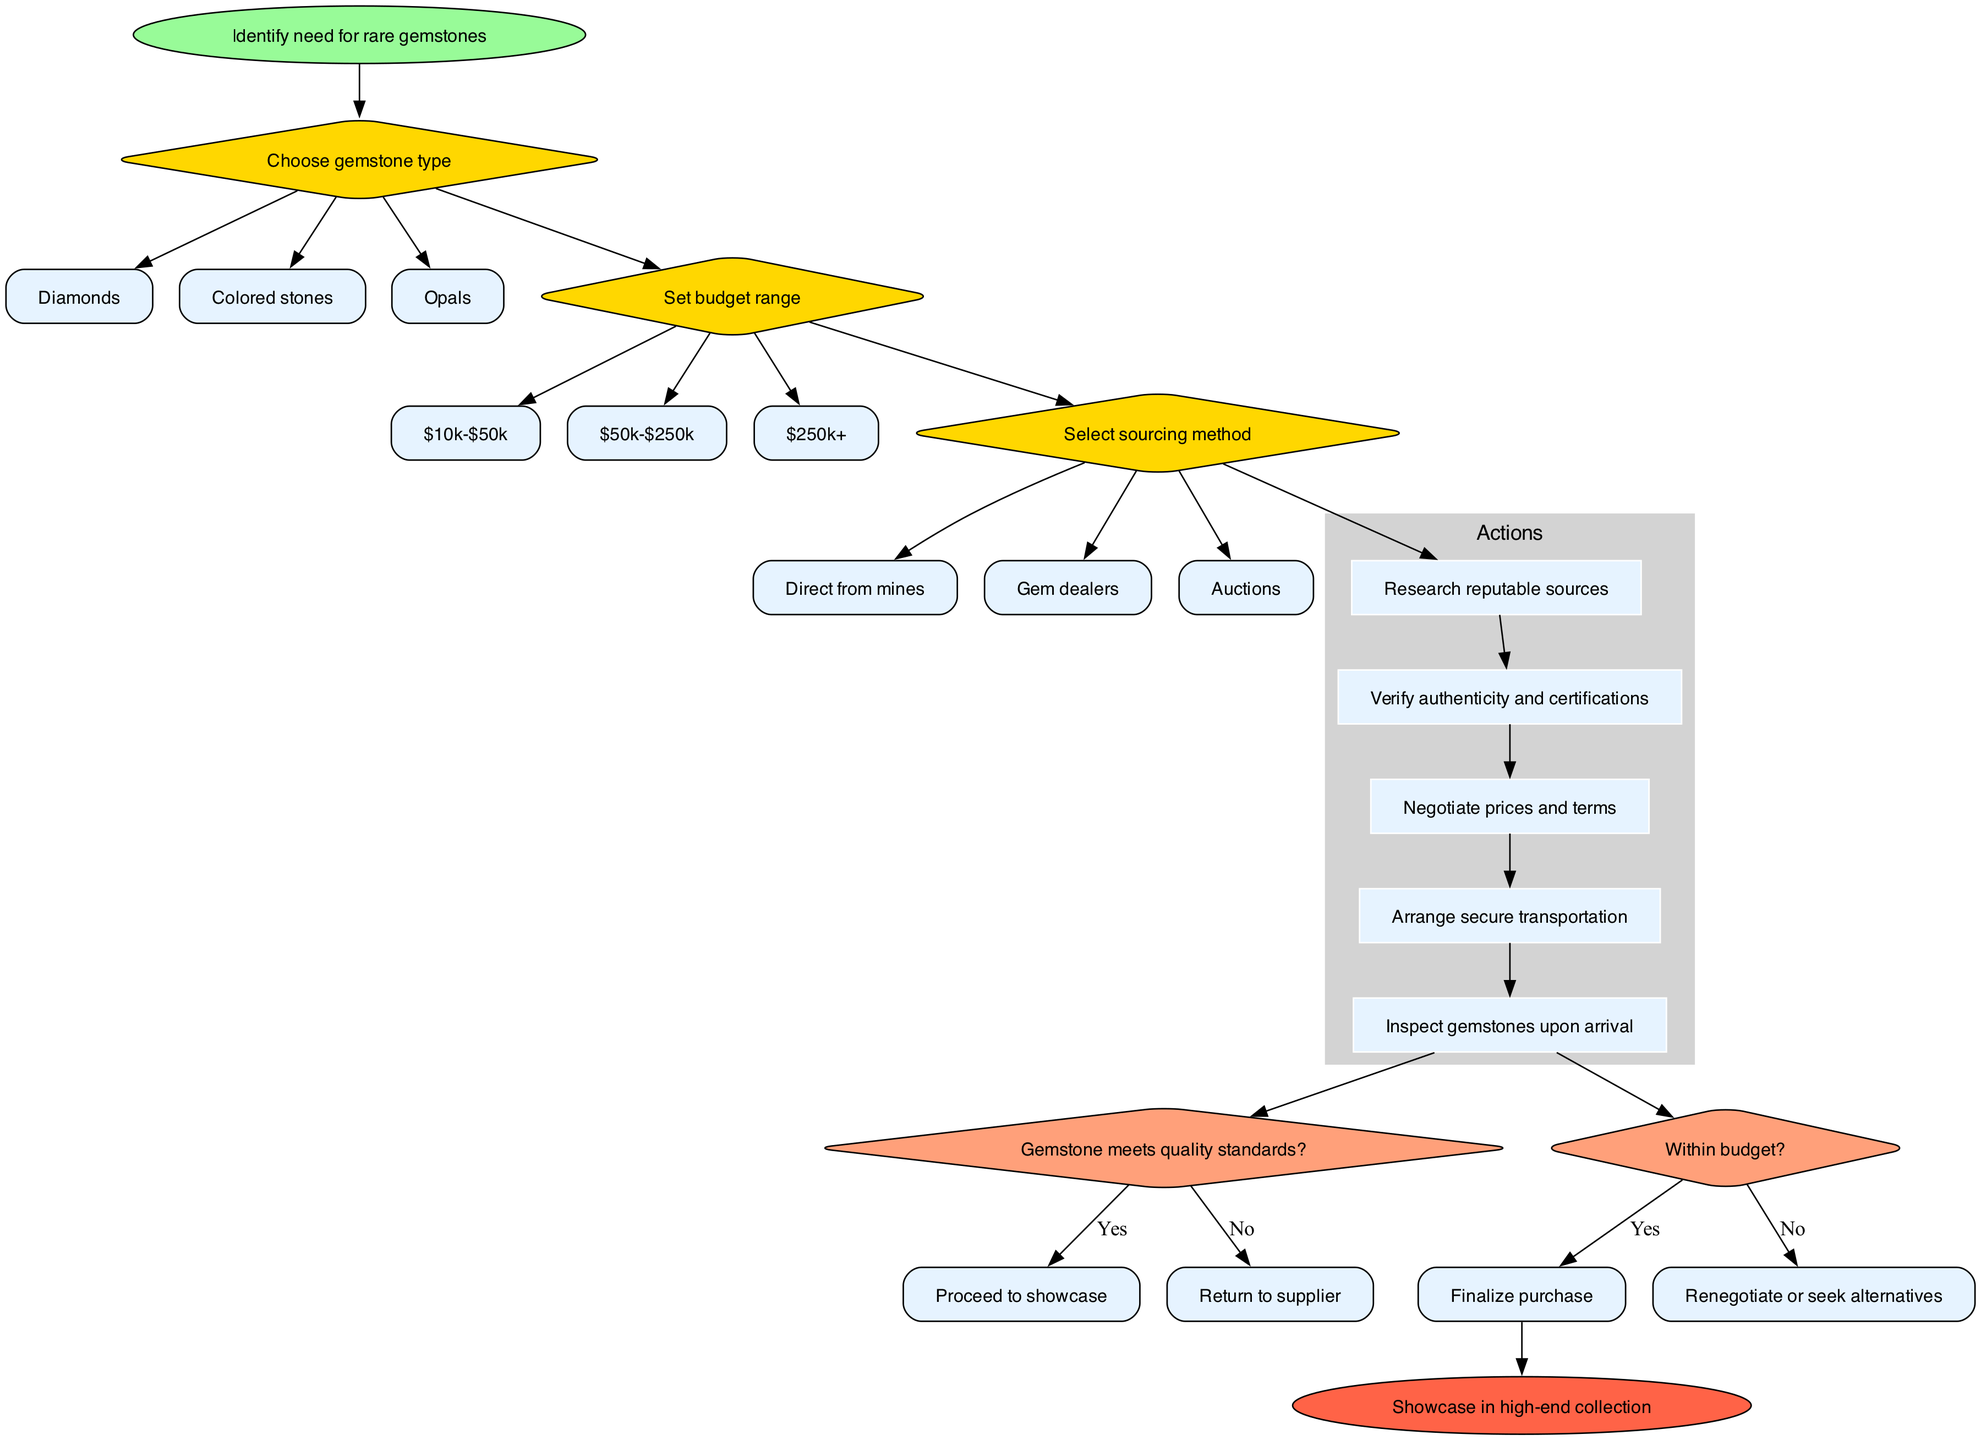What is the starting point of the flowchart? The starting point of the flowchart is labeled "Identify need for rare gemstones," indicating the initial step in the decision-making process.
Answer: Identify need for rare gemstones How many decision nodes are in the flowchart? The flowchart contains three decision nodes, each addressing a different aspect of gemstone sourcing: gemstone type, budget range, and sourcing method.
Answer: 3 What are the options for the "Choose gemstone type" decision? The options for the "Choose gemstone type" decision include: Diamonds, Colored stones, and Opals, which are presented as the possible selections for the type of gemstone.
Answer: Diamonds, Colored stones, Opals What happens if a gemstone does not meet quality standards? If a gemstone does not meet quality standards, the flowchart indicates the process will "Return to supplier," suggesting that the procurement will not proceed with this gemstone.
Answer: Return to supplier What is the final outcome of the flowchart? The final outcome of the flowchart is to "Showcase in high-end collection," which represents the ultimate goal of the gemstone sourcing and procurement process after all conditions have been satisfied.
Answer: Showcase in high-end collection If the chosen gemstone type is Colored stones, which node comes next? Following the selection of Colored stones, the next node would be to set the budget range, as these decisions are sequentially connected in the flowchart.
Answer: Set budget range What actions are taken after selecting the sourcing method? After selecting the sourcing method, the actions taken include researching reputable sources, verifying authenticity, negotiating prices, arranging secure transportation, and inspecting gemstones upon arrival, which follow in sequence after making the decision on sourcing.
Answer: Research reputable sources, Verify authenticity and certifications, Negotiate prices and terms, Arrange secure transportation, Inspect gemstones upon arrival What condition must be satisfied to finalize the purchase? To finalize the purchase, the condition states "Within budget?" which must be met; if this condition is satisfied, the purchase is completed.
Answer: Within budget? What is the first action mentioned in the flowchart? The first action mentioned in the flowchart is "Research reputable sources," which is the initial step taken after the decisions have been made.
Answer: Research reputable sources 